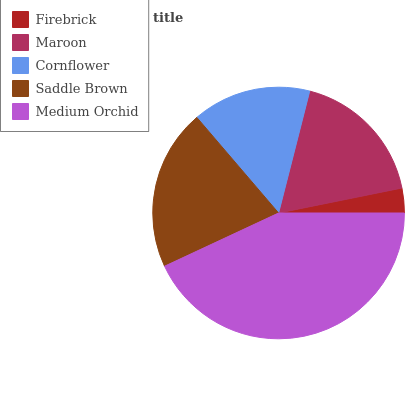Is Firebrick the minimum?
Answer yes or no. Yes. Is Medium Orchid the maximum?
Answer yes or no. Yes. Is Maroon the minimum?
Answer yes or no. No. Is Maroon the maximum?
Answer yes or no. No. Is Maroon greater than Firebrick?
Answer yes or no. Yes. Is Firebrick less than Maroon?
Answer yes or no. Yes. Is Firebrick greater than Maroon?
Answer yes or no. No. Is Maroon less than Firebrick?
Answer yes or no. No. Is Maroon the high median?
Answer yes or no. Yes. Is Maroon the low median?
Answer yes or no. Yes. Is Firebrick the high median?
Answer yes or no. No. Is Saddle Brown the low median?
Answer yes or no. No. 